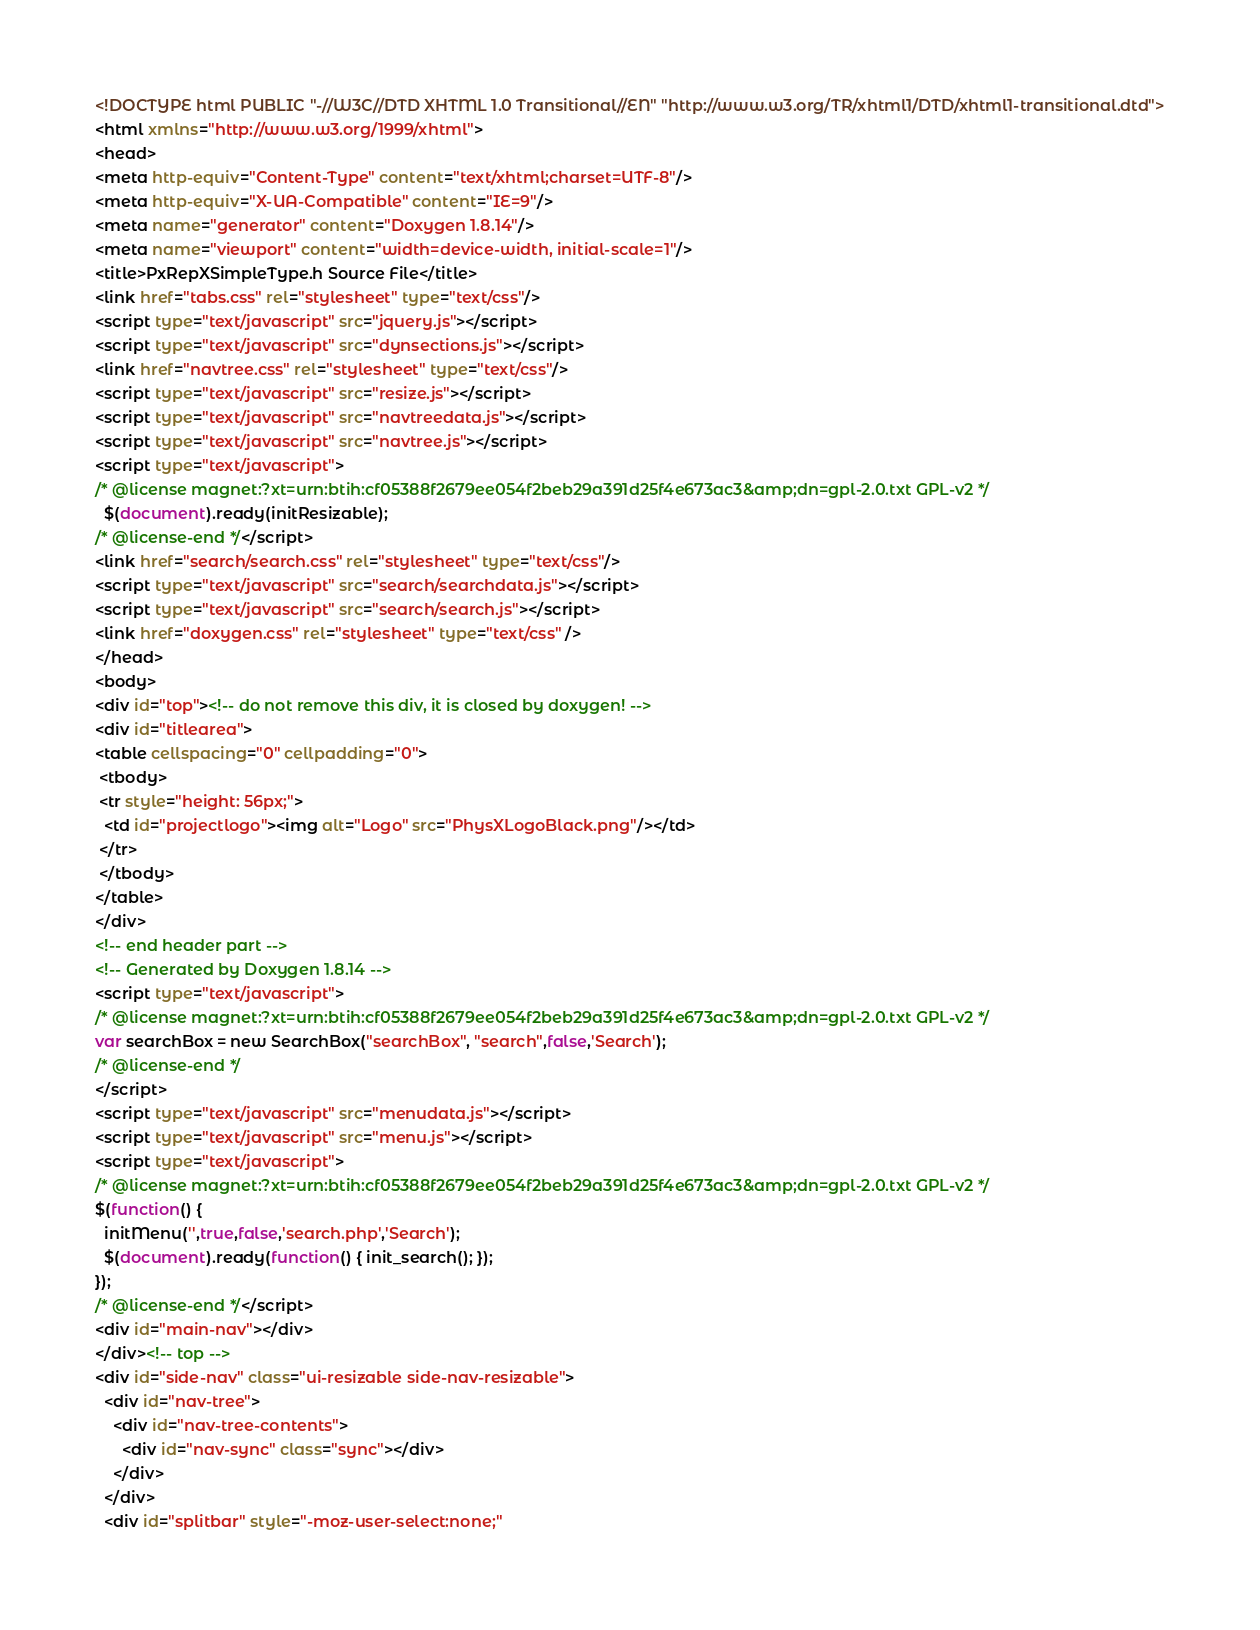Convert code to text. <code><loc_0><loc_0><loc_500><loc_500><_HTML_><!DOCTYPE html PUBLIC "-//W3C//DTD XHTML 1.0 Transitional//EN" "http://www.w3.org/TR/xhtml1/DTD/xhtml1-transitional.dtd">
<html xmlns="http://www.w3.org/1999/xhtml">
<head>
<meta http-equiv="Content-Type" content="text/xhtml;charset=UTF-8"/>
<meta http-equiv="X-UA-Compatible" content="IE=9"/>
<meta name="generator" content="Doxygen 1.8.14"/>
<meta name="viewport" content="width=device-width, initial-scale=1"/>
<title>PxRepXSimpleType.h Source File</title>
<link href="tabs.css" rel="stylesheet" type="text/css"/>
<script type="text/javascript" src="jquery.js"></script>
<script type="text/javascript" src="dynsections.js"></script>
<link href="navtree.css" rel="stylesheet" type="text/css"/>
<script type="text/javascript" src="resize.js"></script>
<script type="text/javascript" src="navtreedata.js"></script>
<script type="text/javascript" src="navtree.js"></script>
<script type="text/javascript">
/* @license magnet:?xt=urn:btih:cf05388f2679ee054f2beb29a391d25f4e673ac3&amp;dn=gpl-2.0.txt GPL-v2 */
  $(document).ready(initResizable);
/* @license-end */</script>
<link href="search/search.css" rel="stylesheet" type="text/css"/>
<script type="text/javascript" src="search/searchdata.js"></script>
<script type="text/javascript" src="search/search.js"></script>
<link href="doxygen.css" rel="stylesheet" type="text/css" />
</head>
<body>
<div id="top"><!-- do not remove this div, it is closed by doxygen! -->
<div id="titlearea">
<table cellspacing="0" cellpadding="0">
 <tbody>
 <tr style="height: 56px;">
  <td id="projectlogo"><img alt="Logo" src="PhysXLogoBlack.png"/></td>
 </tr>
 </tbody>
</table>
</div>
<!-- end header part -->
<!-- Generated by Doxygen 1.8.14 -->
<script type="text/javascript">
/* @license magnet:?xt=urn:btih:cf05388f2679ee054f2beb29a391d25f4e673ac3&amp;dn=gpl-2.0.txt GPL-v2 */
var searchBox = new SearchBox("searchBox", "search",false,'Search');
/* @license-end */
</script>
<script type="text/javascript" src="menudata.js"></script>
<script type="text/javascript" src="menu.js"></script>
<script type="text/javascript">
/* @license magnet:?xt=urn:btih:cf05388f2679ee054f2beb29a391d25f4e673ac3&amp;dn=gpl-2.0.txt GPL-v2 */
$(function() {
  initMenu('',true,false,'search.php','Search');
  $(document).ready(function() { init_search(); });
});
/* @license-end */</script>
<div id="main-nav"></div>
</div><!-- top -->
<div id="side-nav" class="ui-resizable side-nav-resizable">
  <div id="nav-tree">
    <div id="nav-tree-contents">
      <div id="nav-sync" class="sync"></div>
    </div>
  </div>
  <div id="splitbar" style="-moz-user-select:none;" </code> 